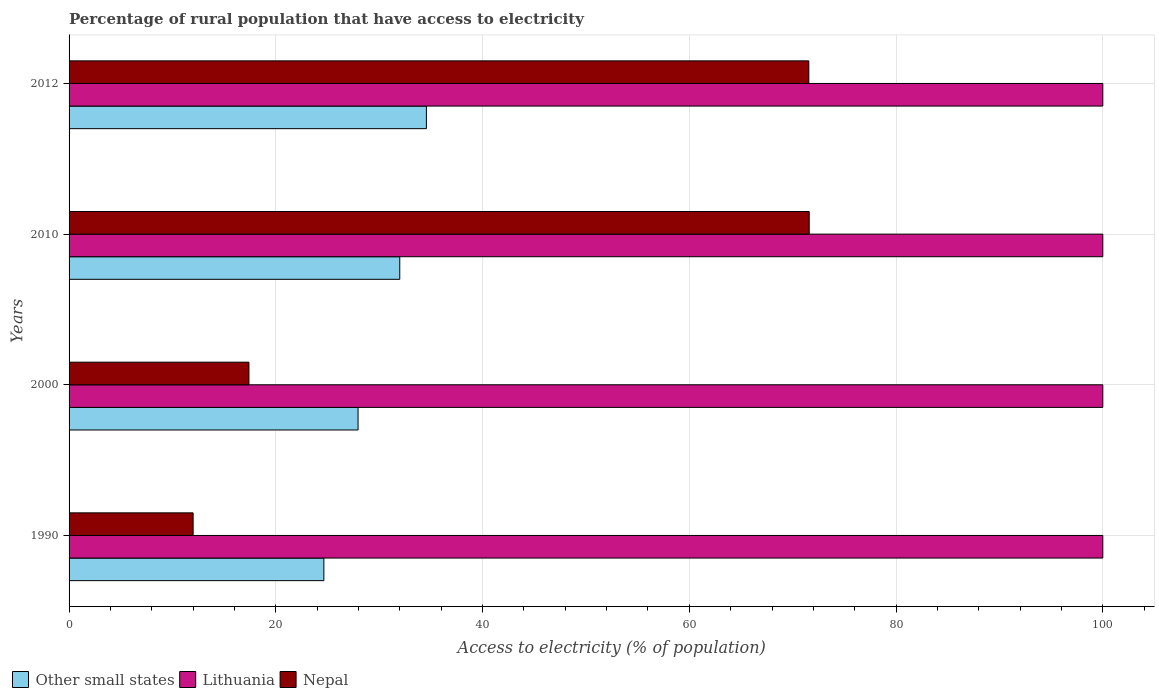Are the number of bars per tick equal to the number of legend labels?
Offer a very short reply. Yes. What is the label of the 4th group of bars from the top?
Provide a short and direct response. 1990. What is the percentage of rural population that have access to electricity in Other small states in 2000?
Your answer should be compact. 27.96. Across all years, what is the maximum percentage of rural population that have access to electricity in Lithuania?
Ensure brevity in your answer.  100. In which year was the percentage of rural population that have access to electricity in Nepal maximum?
Offer a terse response. 2010. What is the total percentage of rural population that have access to electricity in Lithuania in the graph?
Provide a succinct answer. 400. What is the difference between the percentage of rural population that have access to electricity in Other small states in 2000 and that in 2012?
Make the answer very short. -6.61. What is the difference between the percentage of rural population that have access to electricity in Nepal in 2010 and the percentage of rural population that have access to electricity in Lithuania in 2012?
Your response must be concise. -28.4. What is the average percentage of rural population that have access to electricity in Other small states per year?
Your response must be concise. 29.79. In the year 2012, what is the difference between the percentage of rural population that have access to electricity in Other small states and percentage of rural population that have access to electricity in Nepal?
Your response must be concise. -36.99. In how many years, is the percentage of rural population that have access to electricity in Nepal greater than 92 %?
Your answer should be compact. 0. What is the ratio of the percentage of rural population that have access to electricity in Lithuania in 2000 to that in 2012?
Make the answer very short. 1. Is the percentage of rural population that have access to electricity in Lithuania in 2010 less than that in 2012?
Provide a short and direct response. No. What is the difference between the highest and the second highest percentage of rural population that have access to electricity in Lithuania?
Your answer should be compact. 0. What is the difference between the highest and the lowest percentage of rural population that have access to electricity in Other small states?
Ensure brevity in your answer.  9.92. In how many years, is the percentage of rural population that have access to electricity in Other small states greater than the average percentage of rural population that have access to electricity in Other small states taken over all years?
Your answer should be very brief. 2. Is the sum of the percentage of rural population that have access to electricity in Other small states in 2000 and 2010 greater than the maximum percentage of rural population that have access to electricity in Nepal across all years?
Ensure brevity in your answer.  No. What does the 2nd bar from the top in 2012 represents?
Make the answer very short. Lithuania. What does the 2nd bar from the bottom in 2012 represents?
Keep it short and to the point. Lithuania. Is it the case that in every year, the sum of the percentage of rural population that have access to electricity in Nepal and percentage of rural population that have access to electricity in Other small states is greater than the percentage of rural population that have access to electricity in Lithuania?
Provide a short and direct response. No. How many bars are there?
Keep it short and to the point. 12. Are all the bars in the graph horizontal?
Make the answer very short. Yes. Does the graph contain any zero values?
Your response must be concise. No. Where does the legend appear in the graph?
Offer a very short reply. Bottom left. How many legend labels are there?
Ensure brevity in your answer.  3. What is the title of the graph?
Offer a very short reply. Percentage of rural population that have access to electricity. Does "Middle income" appear as one of the legend labels in the graph?
Your response must be concise. No. What is the label or title of the X-axis?
Offer a very short reply. Access to electricity (% of population). What is the label or title of the Y-axis?
Keep it short and to the point. Years. What is the Access to electricity (% of population) in Other small states in 1990?
Provide a succinct answer. 24.65. What is the Access to electricity (% of population) in Lithuania in 1990?
Your response must be concise. 100. What is the Access to electricity (% of population) of Other small states in 2000?
Give a very brief answer. 27.96. What is the Access to electricity (% of population) of Lithuania in 2000?
Keep it short and to the point. 100. What is the Access to electricity (% of population) of Nepal in 2000?
Ensure brevity in your answer.  17.4. What is the Access to electricity (% of population) of Other small states in 2010?
Offer a terse response. 31.99. What is the Access to electricity (% of population) of Nepal in 2010?
Your answer should be compact. 71.6. What is the Access to electricity (% of population) of Other small states in 2012?
Provide a short and direct response. 34.57. What is the Access to electricity (% of population) in Lithuania in 2012?
Offer a very short reply. 100. What is the Access to electricity (% of population) of Nepal in 2012?
Your answer should be very brief. 71.56. Across all years, what is the maximum Access to electricity (% of population) of Other small states?
Offer a very short reply. 34.57. Across all years, what is the maximum Access to electricity (% of population) of Lithuania?
Ensure brevity in your answer.  100. Across all years, what is the maximum Access to electricity (% of population) of Nepal?
Provide a short and direct response. 71.6. Across all years, what is the minimum Access to electricity (% of population) in Other small states?
Your answer should be compact. 24.65. What is the total Access to electricity (% of population) of Other small states in the graph?
Your answer should be compact. 119.16. What is the total Access to electricity (% of population) of Nepal in the graph?
Offer a very short reply. 172.56. What is the difference between the Access to electricity (% of population) of Other small states in 1990 and that in 2000?
Ensure brevity in your answer.  -3.31. What is the difference between the Access to electricity (% of population) of Lithuania in 1990 and that in 2000?
Your response must be concise. 0. What is the difference between the Access to electricity (% of population) in Nepal in 1990 and that in 2000?
Your answer should be very brief. -5.4. What is the difference between the Access to electricity (% of population) in Other small states in 1990 and that in 2010?
Your answer should be compact. -7.34. What is the difference between the Access to electricity (% of population) in Lithuania in 1990 and that in 2010?
Your answer should be very brief. 0. What is the difference between the Access to electricity (% of population) of Nepal in 1990 and that in 2010?
Your answer should be very brief. -59.6. What is the difference between the Access to electricity (% of population) in Other small states in 1990 and that in 2012?
Ensure brevity in your answer.  -9.92. What is the difference between the Access to electricity (% of population) in Lithuania in 1990 and that in 2012?
Your response must be concise. 0. What is the difference between the Access to electricity (% of population) in Nepal in 1990 and that in 2012?
Make the answer very short. -59.56. What is the difference between the Access to electricity (% of population) in Other small states in 2000 and that in 2010?
Keep it short and to the point. -4.04. What is the difference between the Access to electricity (% of population) of Nepal in 2000 and that in 2010?
Your answer should be compact. -54.2. What is the difference between the Access to electricity (% of population) in Other small states in 2000 and that in 2012?
Make the answer very short. -6.61. What is the difference between the Access to electricity (% of population) of Nepal in 2000 and that in 2012?
Offer a terse response. -54.16. What is the difference between the Access to electricity (% of population) of Other small states in 2010 and that in 2012?
Your answer should be very brief. -2.58. What is the difference between the Access to electricity (% of population) of Lithuania in 2010 and that in 2012?
Ensure brevity in your answer.  0. What is the difference between the Access to electricity (% of population) in Nepal in 2010 and that in 2012?
Offer a very short reply. 0.04. What is the difference between the Access to electricity (% of population) in Other small states in 1990 and the Access to electricity (% of population) in Lithuania in 2000?
Give a very brief answer. -75.35. What is the difference between the Access to electricity (% of population) in Other small states in 1990 and the Access to electricity (% of population) in Nepal in 2000?
Your answer should be compact. 7.25. What is the difference between the Access to electricity (% of population) of Lithuania in 1990 and the Access to electricity (% of population) of Nepal in 2000?
Provide a succinct answer. 82.6. What is the difference between the Access to electricity (% of population) of Other small states in 1990 and the Access to electricity (% of population) of Lithuania in 2010?
Make the answer very short. -75.35. What is the difference between the Access to electricity (% of population) in Other small states in 1990 and the Access to electricity (% of population) in Nepal in 2010?
Provide a short and direct response. -46.95. What is the difference between the Access to electricity (% of population) of Lithuania in 1990 and the Access to electricity (% of population) of Nepal in 2010?
Ensure brevity in your answer.  28.4. What is the difference between the Access to electricity (% of population) in Other small states in 1990 and the Access to electricity (% of population) in Lithuania in 2012?
Keep it short and to the point. -75.35. What is the difference between the Access to electricity (% of population) of Other small states in 1990 and the Access to electricity (% of population) of Nepal in 2012?
Your response must be concise. -46.91. What is the difference between the Access to electricity (% of population) in Lithuania in 1990 and the Access to electricity (% of population) in Nepal in 2012?
Your answer should be very brief. 28.44. What is the difference between the Access to electricity (% of population) in Other small states in 2000 and the Access to electricity (% of population) in Lithuania in 2010?
Offer a terse response. -72.04. What is the difference between the Access to electricity (% of population) of Other small states in 2000 and the Access to electricity (% of population) of Nepal in 2010?
Ensure brevity in your answer.  -43.64. What is the difference between the Access to electricity (% of population) of Lithuania in 2000 and the Access to electricity (% of population) of Nepal in 2010?
Offer a terse response. 28.4. What is the difference between the Access to electricity (% of population) of Other small states in 2000 and the Access to electricity (% of population) of Lithuania in 2012?
Offer a terse response. -72.04. What is the difference between the Access to electricity (% of population) of Other small states in 2000 and the Access to electricity (% of population) of Nepal in 2012?
Provide a short and direct response. -43.6. What is the difference between the Access to electricity (% of population) of Lithuania in 2000 and the Access to electricity (% of population) of Nepal in 2012?
Your answer should be very brief. 28.44. What is the difference between the Access to electricity (% of population) in Other small states in 2010 and the Access to electricity (% of population) in Lithuania in 2012?
Your answer should be very brief. -68.01. What is the difference between the Access to electricity (% of population) of Other small states in 2010 and the Access to electricity (% of population) of Nepal in 2012?
Provide a short and direct response. -39.57. What is the difference between the Access to electricity (% of population) in Lithuania in 2010 and the Access to electricity (% of population) in Nepal in 2012?
Provide a short and direct response. 28.44. What is the average Access to electricity (% of population) of Other small states per year?
Provide a succinct answer. 29.79. What is the average Access to electricity (% of population) in Lithuania per year?
Provide a succinct answer. 100. What is the average Access to electricity (% of population) in Nepal per year?
Your answer should be very brief. 43.14. In the year 1990, what is the difference between the Access to electricity (% of population) of Other small states and Access to electricity (% of population) of Lithuania?
Offer a terse response. -75.35. In the year 1990, what is the difference between the Access to electricity (% of population) in Other small states and Access to electricity (% of population) in Nepal?
Provide a short and direct response. 12.65. In the year 2000, what is the difference between the Access to electricity (% of population) in Other small states and Access to electricity (% of population) in Lithuania?
Provide a short and direct response. -72.04. In the year 2000, what is the difference between the Access to electricity (% of population) in Other small states and Access to electricity (% of population) in Nepal?
Ensure brevity in your answer.  10.56. In the year 2000, what is the difference between the Access to electricity (% of population) of Lithuania and Access to electricity (% of population) of Nepal?
Offer a terse response. 82.6. In the year 2010, what is the difference between the Access to electricity (% of population) in Other small states and Access to electricity (% of population) in Lithuania?
Provide a short and direct response. -68.01. In the year 2010, what is the difference between the Access to electricity (% of population) in Other small states and Access to electricity (% of population) in Nepal?
Provide a succinct answer. -39.61. In the year 2010, what is the difference between the Access to electricity (% of population) of Lithuania and Access to electricity (% of population) of Nepal?
Keep it short and to the point. 28.4. In the year 2012, what is the difference between the Access to electricity (% of population) of Other small states and Access to electricity (% of population) of Lithuania?
Offer a very short reply. -65.43. In the year 2012, what is the difference between the Access to electricity (% of population) of Other small states and Access to electricity (% of population) of Nepal?
Give a very brief answer. -36.99. In the year 2012, what is the difference between the Access to electricity (% of population) in Lithuania and Access to electricity (% of population) in Nepal?
Offer a terse response. 28.44. What is the ratio of the Access to electricity (% of population) of Other small states in 1990 to that in 2000?
Keep it short and to the point. 0.88. What is the ratio of the Access to electricity (% of population) in Nepal in 1990 to that in 2000?
Provide a succinct answer. 0.69. What is the ratio of the Access to electricity (% of population) in Other small states in 1990 to that in 2010?
Keep it short and to the point. 0.77. What is the ratio of the Access to electricity (% of population) of Lithuania in 1990 to that in 2010?
Offer a terse response. 1. What is the ratio of the Access to electricity (% of population) in Nepal in 1990 to that in 2010?
Give a very brief answer. 0.17. What is the ratio of the Access to electricity (% of population) of Other small states in 1990 to that in 2012?
Provide a succinct answer. 0.71. What is the ratio of the Access to electricity (% of population) of Nepal in 1990 to that in 2012?
Offer a very short reply. 0.17. What is the ratio of the Access to electricity (% of population) in Other small states in 2000 to that in 2010?
Provide a short and direct response. 0.87. What is the ratio of the Access to electricity (% of population) in Lithuania in 2000 to that in 2010?
Give a very brief answer. 1. What is the ratio of the Access to electricity (% of population) in Nepal in 2000 to that in 2010?
Your answer should be very brief. 0.24. What is the ratio of the Access to electricity (% of population) in Other small states in 2000 to that in 2012?
Your answer should be very brief. 0.81. What is the ratio of the Access to electricity (% of population) in Lithuania in 2000 to that in 2012?
Offer a terse response. 1. What is the ratio of the Access to electricity (% of population) of Nepal in 2000 to that in 2012?
Your response must be concise. 0.24. What is the ratio of the Access to electricity (% of population) of Other small states in 2010 to that in 2012?
Provide a short and direct response. 0.93. What is the ratio of the Access to electricity (% of population) of Lithuania in 2010 to that in 2012?
Give a very brief answer. 1. What is the difference between the highest and the second highest Access to electricity (% of population) in Other small states?
Offer a very short reply. 2.58. What is the difference between the highest and the second highest Access to electricity (% of population) in Lithuania?
Provide a succinct answer. 0. What is the difference between the highest and the lowest Access to electricity (% of population) of Other small states?
Make the answer very short. 9.92. What is the difference between the highest and the lowest Access to electricity (% of population) in Nepal?
Ensure brevity in your answer.  59.6. 